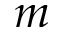Convert formula to latex. <formula><loc_0><loc_0><loc_500><loc_500>m</formula> 